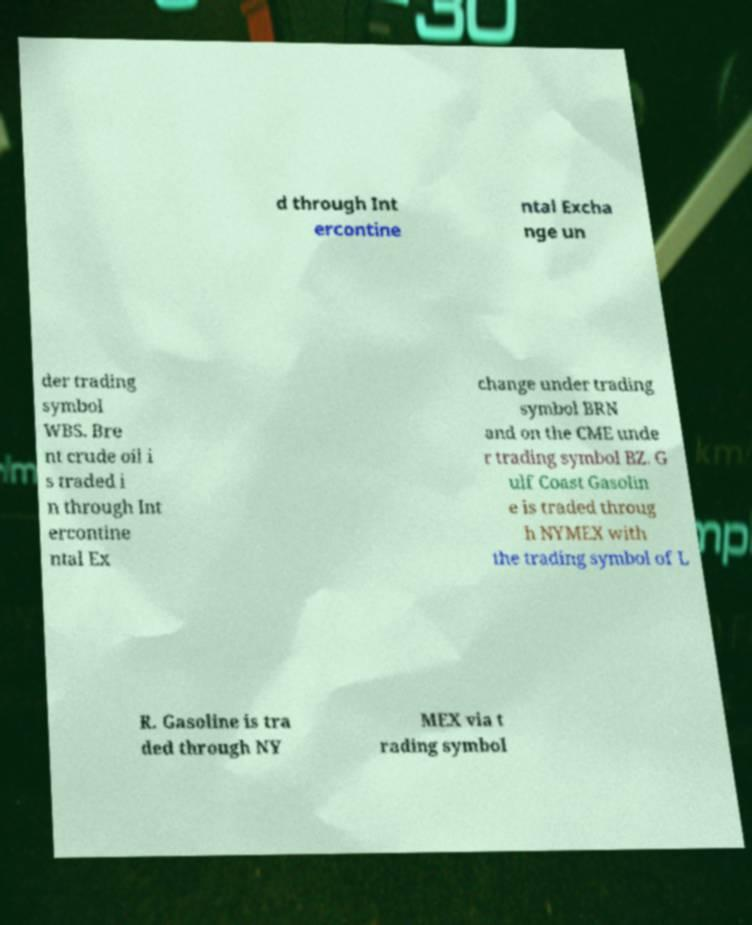I need the written content from this picture converted into text. Can you do that? d through Int ercontine ntal Excha nge un der trading symbol WBS. Bre nt crude oil i s traded i n through Int ercontine ntal Ex change under trading symbol BRN and on the CME unde r trading symbol BZ. G ulf Coast Gasolin e is traded throug h NYMEX with the trading symbol of L R. Gasoline is tra ded through NY MEX via t rading symbol 